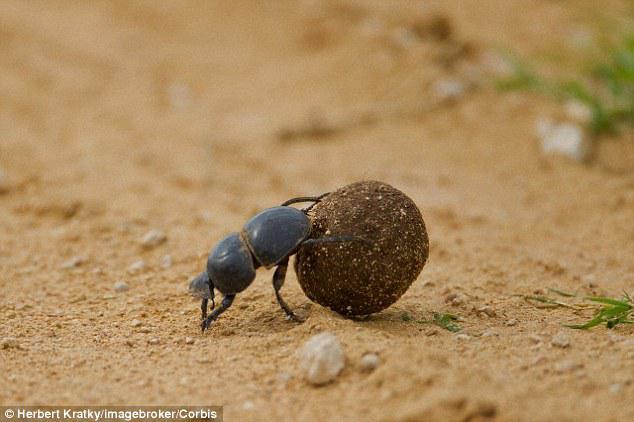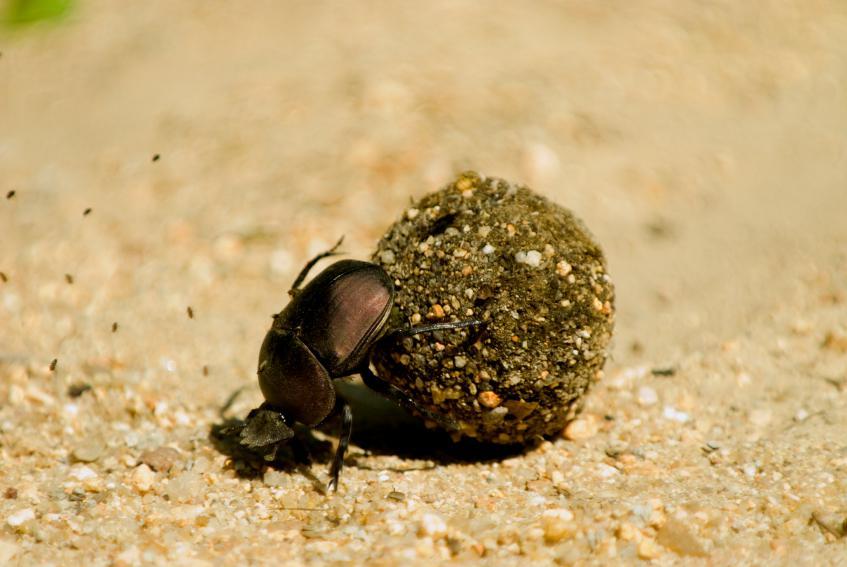The first image is the image on the left, the second image is the image on the right. Given the left and right images, does the statement "There is a beetle that is not in contact with a ball in one image." hold true? Answer yes or no. No. The first image is the image on the left, the second image is the image on the right. For the images displayed, is the sentence "There is a beetle that that's at the very top of a dungball." factually correct? Answer yes or no. No. 